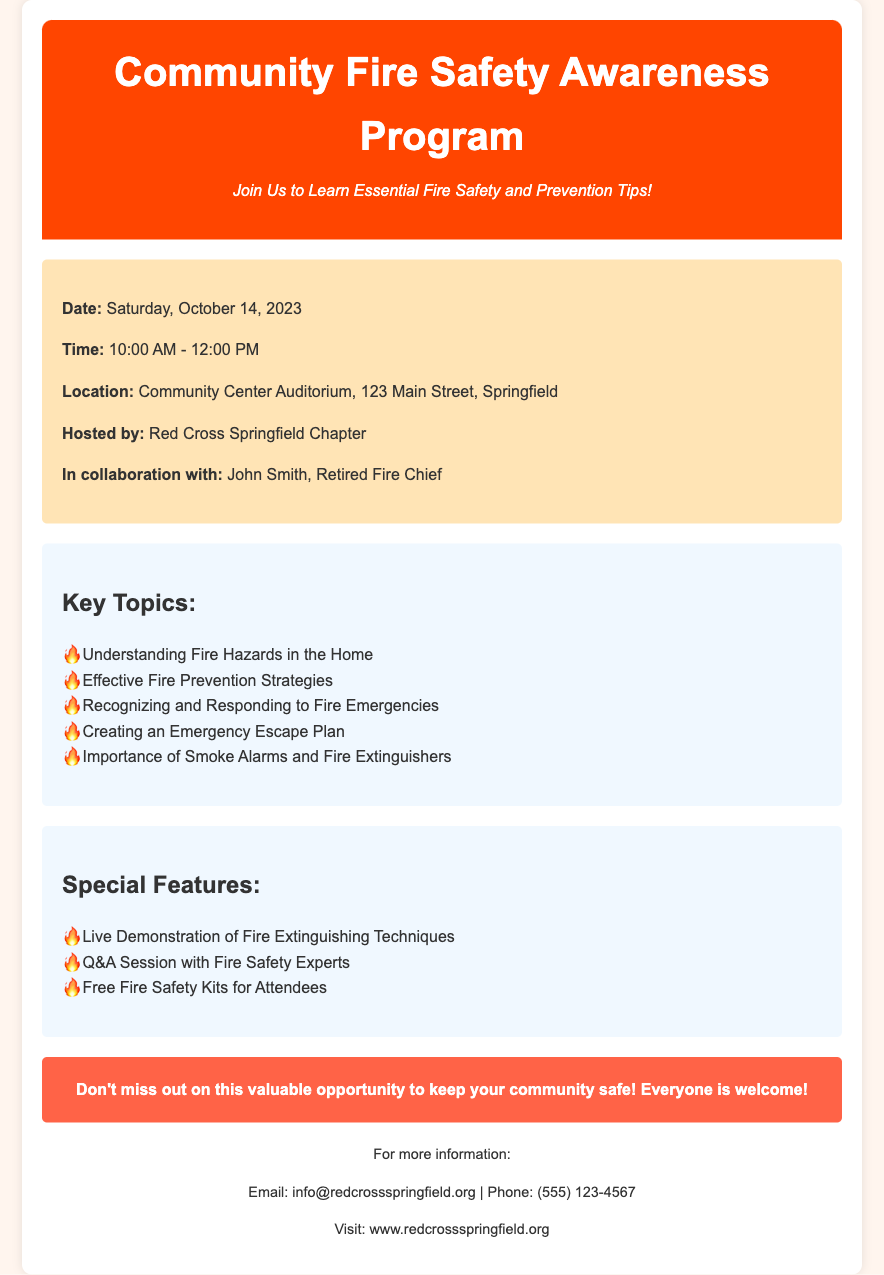What is the date of the event? The date of the event is explicitly stated in the document.
Answer: Saturday, October 14, 2023 What time does the program start? The program start time is specified in the event details section.
Answer: 10:00 AM Where is the event taking place? The location of the event is mentioned in the event details section.
Answer: Community Center Auditorium, 123 Main Street, Springfield Who is collaborating with the Red Cross? The document specifies the collaborator in the hosted by section.
Answer: John Smith, Retired Fire Chief What is one of the key topics covered in the program? The key topics are listed in a bulleted format in the document.
Answer: Understanding Fire Hazards in the Home How long is the fire safety program? The duration can be calculated from the start and end times provided in the document.
Answer: 2 hours What type of special feature will be included in the event? The special features are clearly listed in the document.
Answer: Live Demonstration of Fire Extinguishing Techniques What is included in the free offerings for attendees? The document states what attendees will receive for free.
Answer: Free Fire Safety Kits How can someone get more information about the program? The contact information indicates how to reach out for more information.
Answer: Email: info@redcrossspringfield.org 